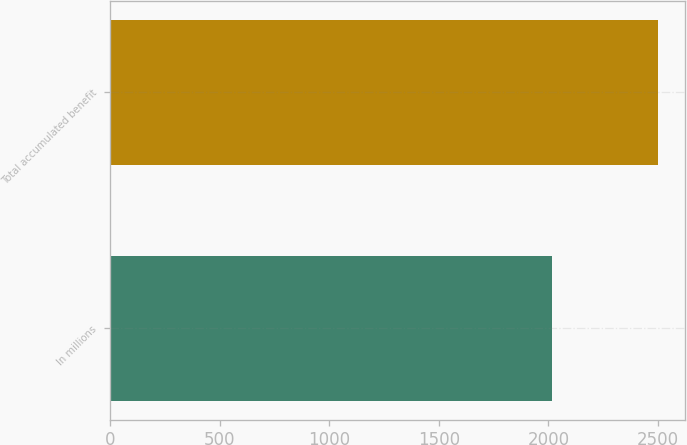<chart> <loc_0><loc_0><loc_500><loc_500><bar_chart><fcel>In millions<fcel>Total accumulated benefit<nl><fcel>2015<fcel>2499<nl></chart> 